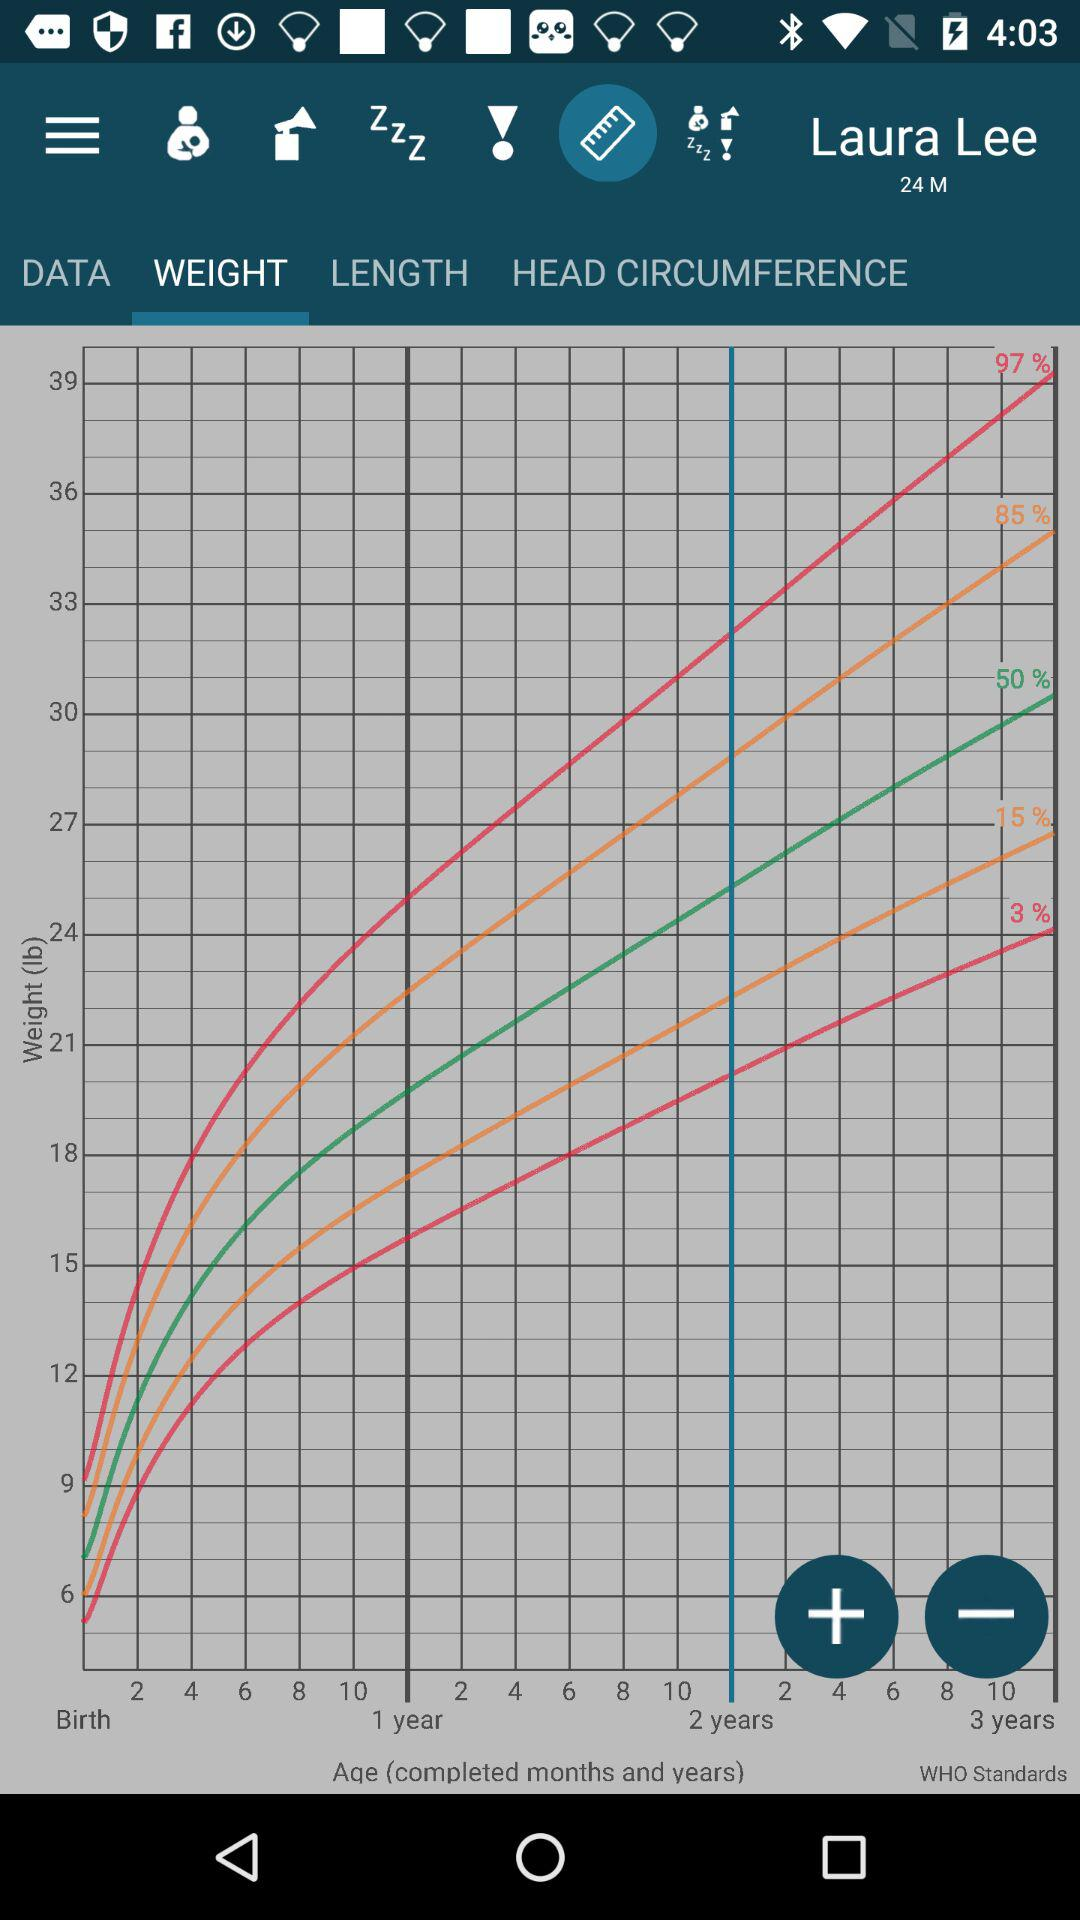What is the name of the child? The name of the child is Laura Lee. 